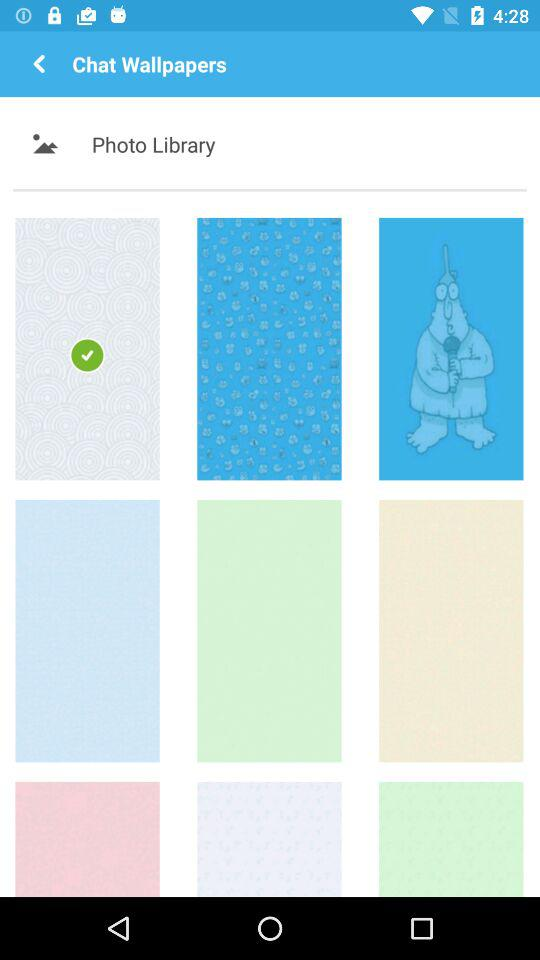What section is mentioned under "Chat Wallpapers"? The mentioned section is "Photo Library". 